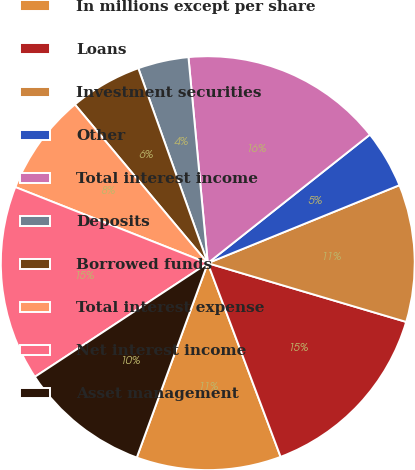Convert chart. <chart><loc_0><loc_0><loc_500><loc_500><pie_chart><fcel>In millions except per share<fcel>Loans<fcel>Investment securities<fcel>Other<fcel>Total interest income<fcel>Deposits<fcel>Borrowed funds<fcel>Total interest expense<fcel>Net interest income<fcel>Asset management<nl><fcel>11.3%<fcel>14.69%<fcel>10.73%<fcel>4.52%<fcel>15.82%<fcel>3.96%<fcel>5.65%<fcel>7.91%<fcel>15.25%<fcel>10.17%<nl></chart> 